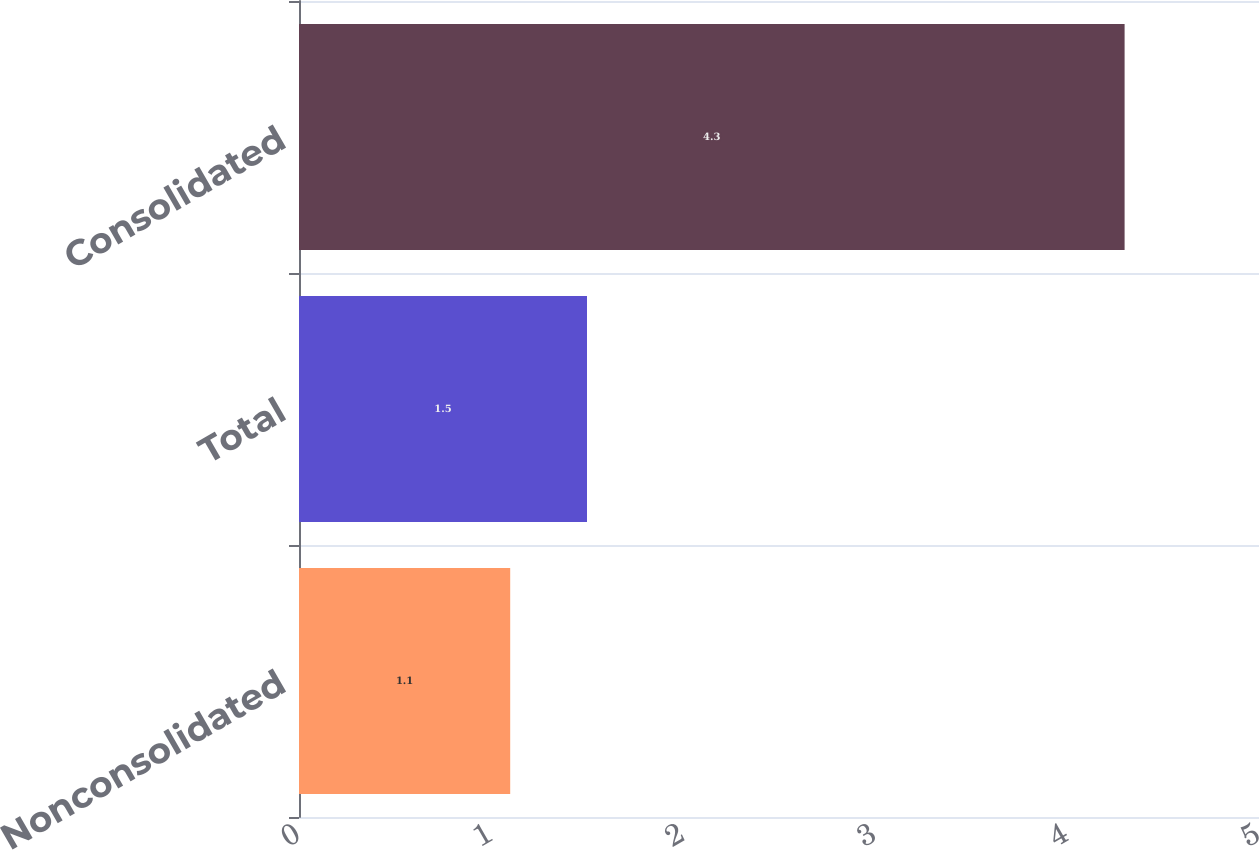Convert chart to OTSL. <chart><loc_0><loc_0><loc_500><loc_500><bar_chart><fcel>Nonconsolidated<fcel>Total<fcel>Consolidated<nl><fcel>1.1<fcel>1.5<fcel>4.3<nl></chart> 